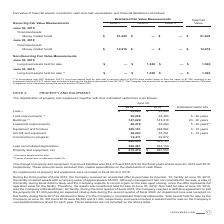According to Jack Henry Associates's financial document, What is the estimated useful life of land improvements? According to the financial document, 5 - 20 years. The relevant text states: "Land improvements (1) 25,209 25,383 5 - 20 years..." Also, What is the estimated useful life of buildings? According to the financial document, 20 - 30 years. The relevant text states: "Buildings (1) 147,220 143,918 20 - 30 years..." Also, What is the estimated useful life of leasehold improvements? According to the financial document, 5 - 30 years. The relevant text states: "Leasehold improvements 48,478 48,060 5 - 30 years (2)..." Also, can you calculate: What is the average land amount for 2018 and 2019? To answer this question, I need to perform calculations using the financial data. The calculation is: (23,243+24,845)/2, which equals 24044. This is based on the information: "Land (1) $ 23,243 $ 24,845 Land (1) $ 23,243 $ 24,845..." The key data points involved are: 23,243, 24,845. Also, can you calculate: What is the average buildings amount for 2018 and 2019? To answer this question, I need to perform calculations using the financial data. The calculation is: (147,220+143,918)/2, which equals 145569. This is based on the information: "Buildings (1) 147,220 143,918 20 - 30 years Buildings (1) 147,220 143,918 20 - 30 years..." The key data points involved are: 143,918, 147,220. Additionally, Between 2018 and 2019 year end, which year had a higher amount of equipment and furniture? According to the financial document, 2019. The relevant text states: "2019 2018 Estimated Useful Life..." 